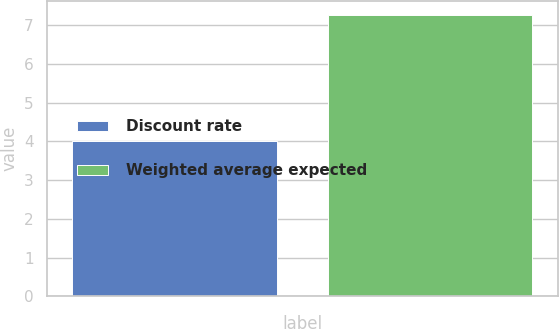Convert chart to OTSL. <chart><loc_0><loc_0><loc_500><loc_500><bar_chart><fcel>Discount rate<fcel>Weighted average expected<nl><fcel>4<fcel>7.25<nl></chart> 